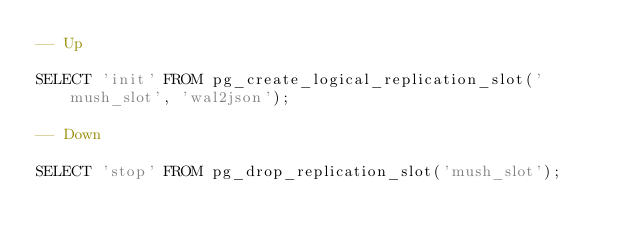Convert code to text. <code><loc_0><loc_0><loc_500><loc_500><_SQL_>-- Up

SELECT 'init' FROM pg_create_logical_replication_slot('mush_slot', 'wal2json');

-- Down

SELECT 'stop' FROM pg_drop_replication_slot('mush_slot');
</code> 